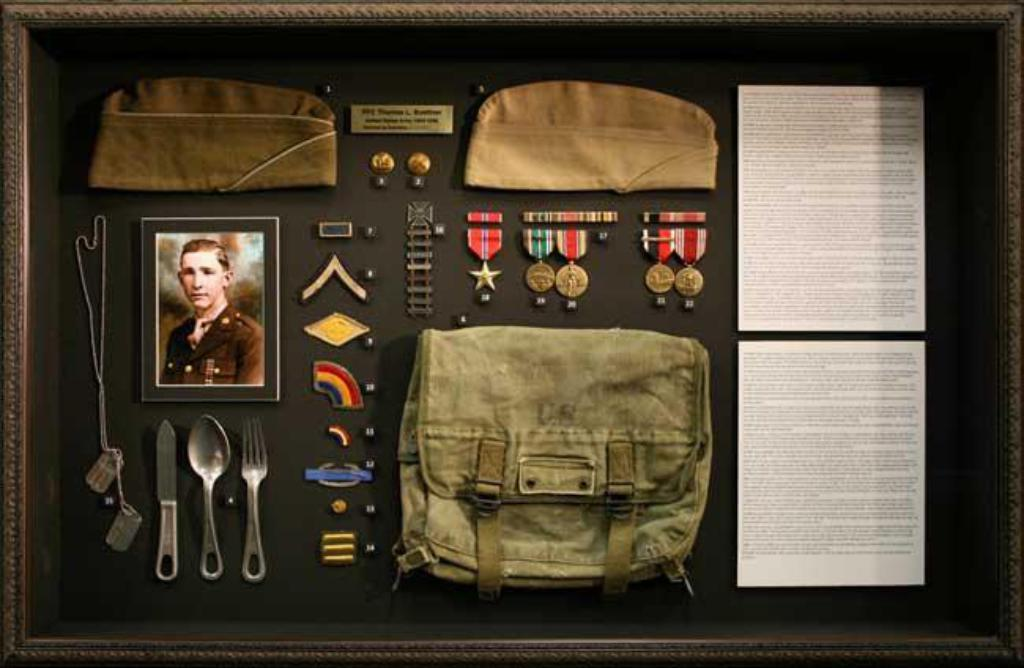What is the main subject of the image? The main subject of the image is a photograph. What utensils can be seen in the image? There is a fork, a spoon, and a knife in the image. What other objects are present in the image? There is a chain, badges, a bag, caps, and papers in the image. What is the color of the surface the objects are on? The surface the objects are on is black. What type of icicle can be seen hanging from the chain in the image? There is no icicle present in the image; it is a chain without any ice. What sound can be heard coming from the badges in the image? There is no sound associated with the badges in the image; they are simply objects in the photograph. 